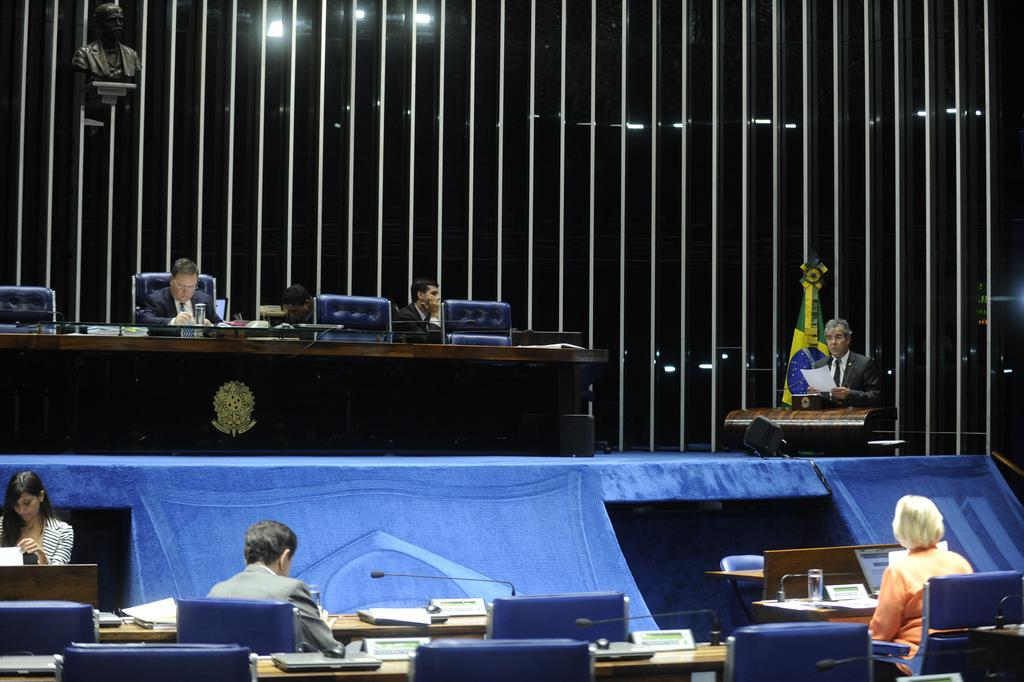What type of room is depicted in the image? There is a meeting hall in the image. What are the people in the image doing? People are seated in the meeting hall. What are the people sitting on in the image? The people are sitting on chairs. What device is present in the image for amplifying sound? There is a microphone in the image. What type of oranges can be seen growing in the meeting hall? There are no oranges present in the meeting hall; it is a room for gatherings and not an agricultural setting. 